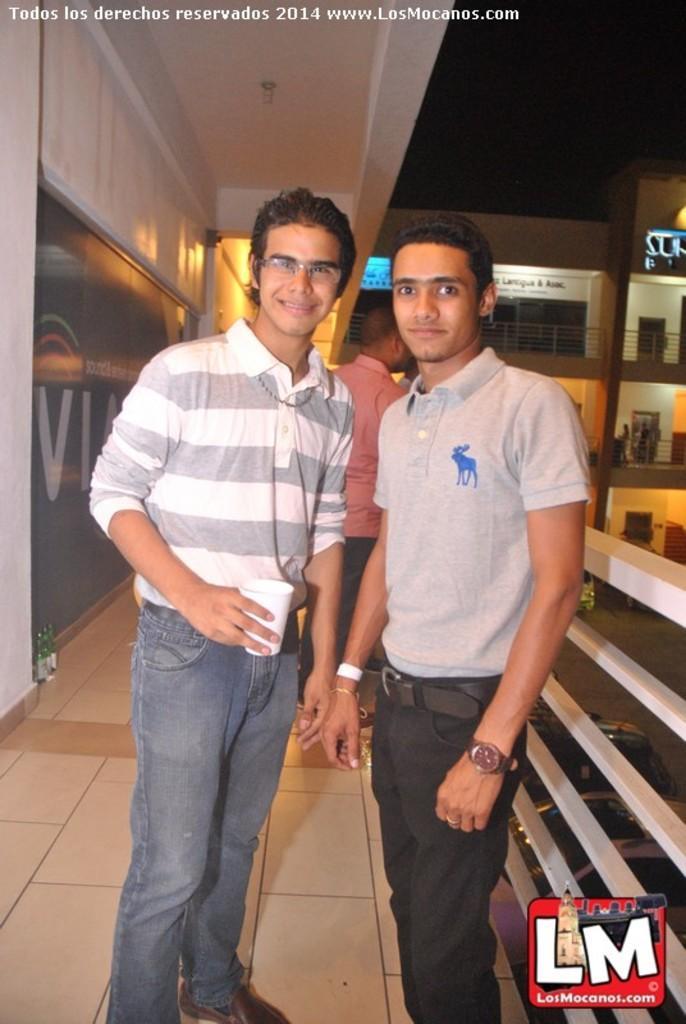Describe this image in one or two sentences. In the image we can see two men standing, wearing clothes and they are smiling. The left side man is wearing a wrist watch and behind them there is another person standing. Here we can see the floor, fence, vehicles and the sky. On the bottom right and top left, we can see the watermark. 